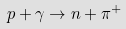Convert formula to latex. <formula><loc_0><loc_0><loc_500><loc_500>p + \gamma \to n + \pi ^ { + }</formula> 